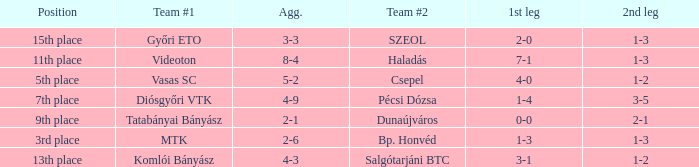What is the team #1 with an 11th place position? Videoton. 